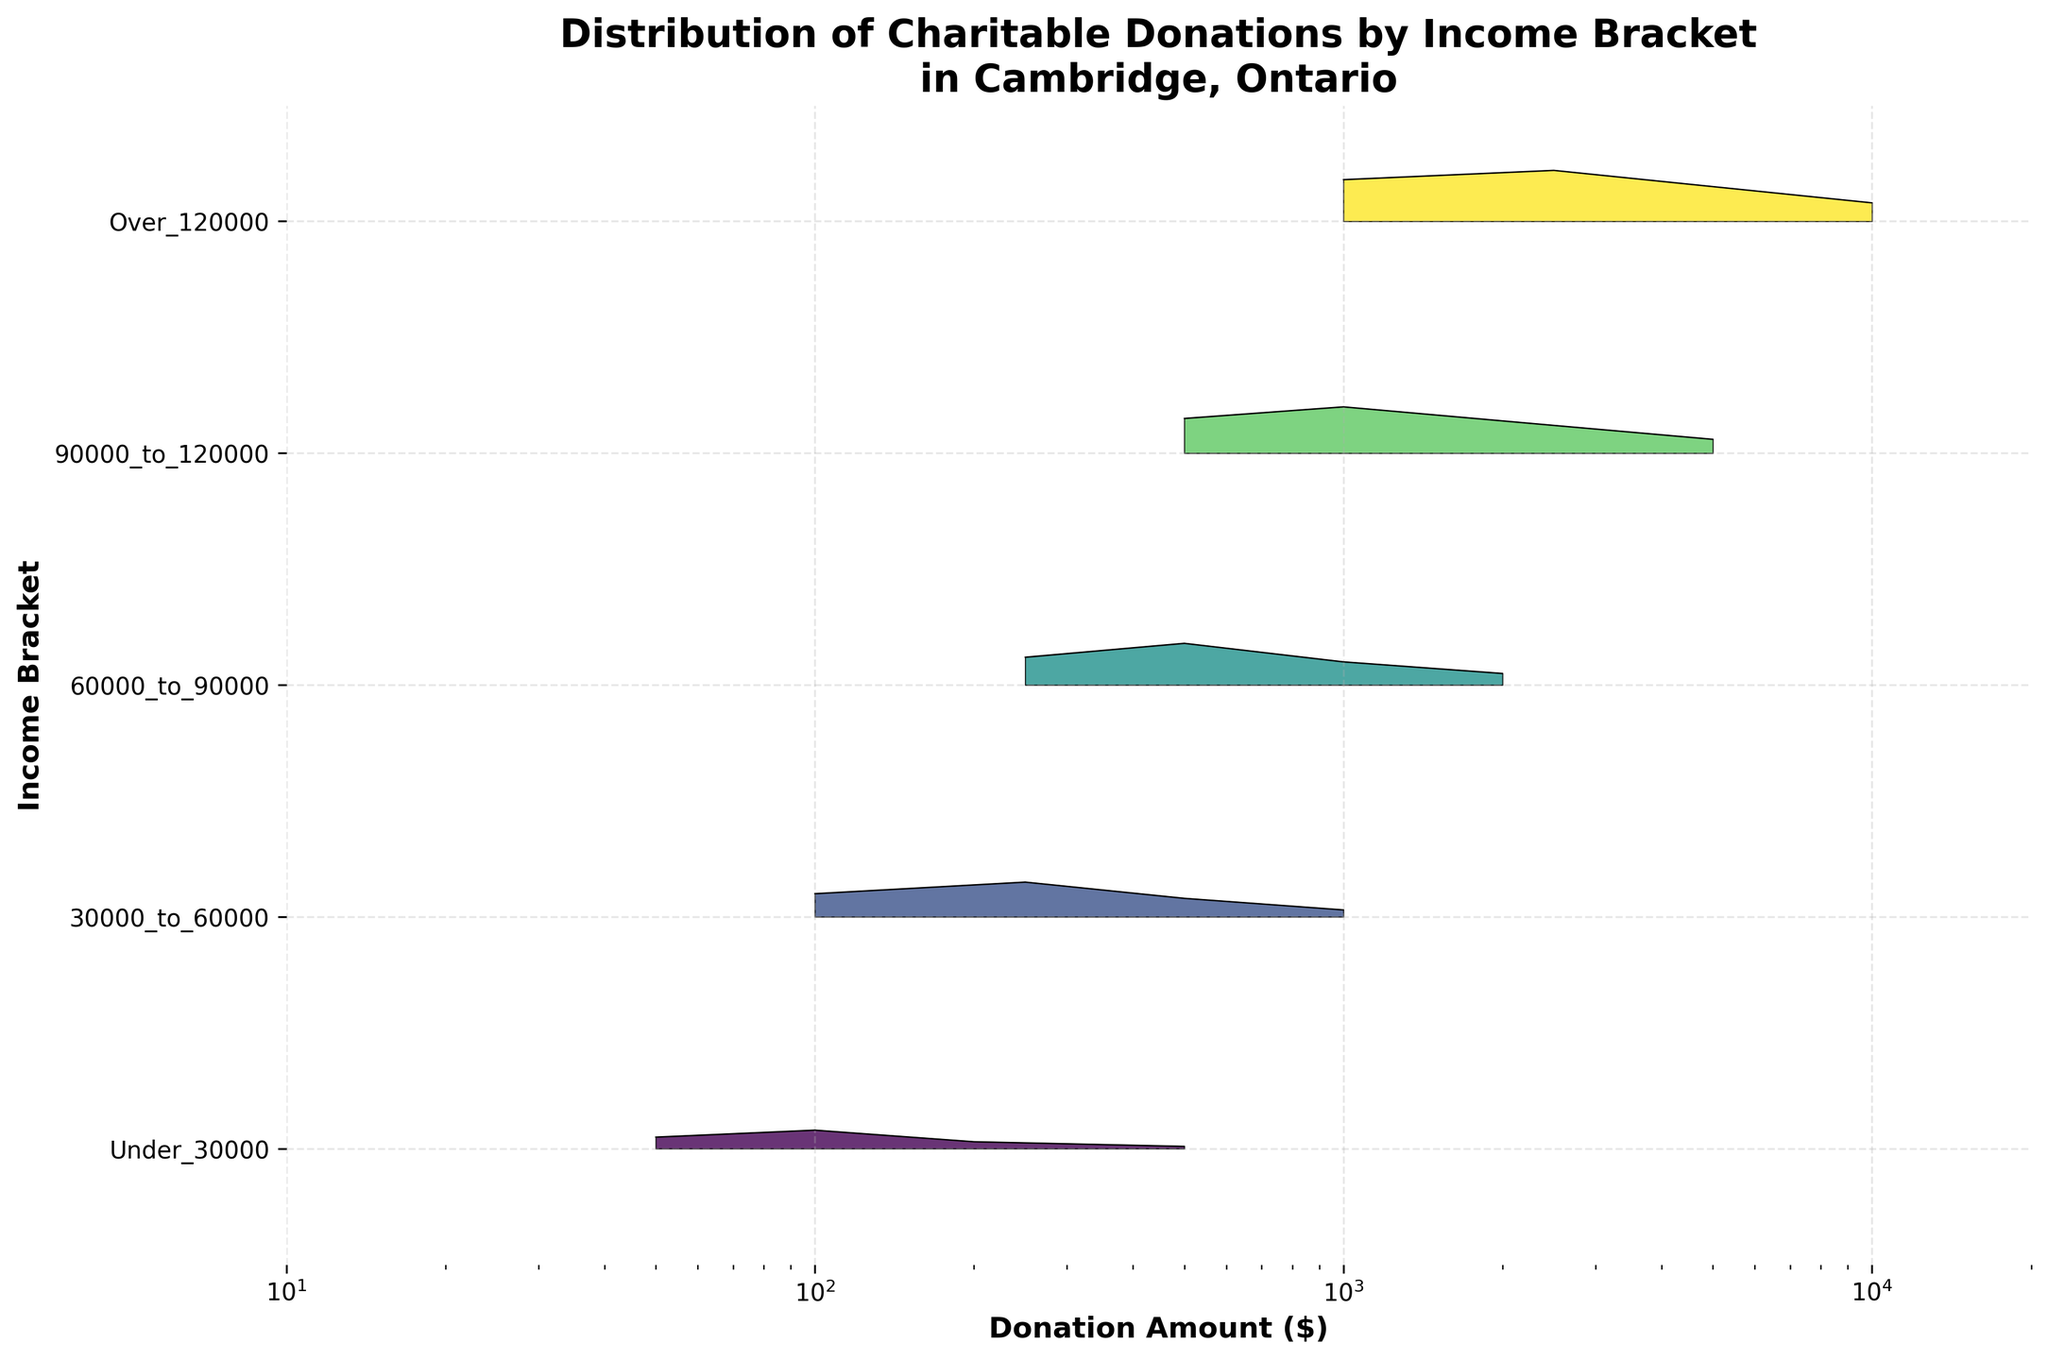what's the title of the figure? The title is located at the top of the figure and typically describes the data being visualized.
Answer: Distribution of Charitable Donations by Income Bracket in Cambridge, Ontario how many income brackets are there in the figure? The y-axis lists the different income brackets being compared. We can count the lines or labels to determine the number of brackets.
Answer: 5 which income bracket exhibits the highest variety of donation amounts? By observing the x-axis and seeing which income bracket has the broadest range of donation amounts, we can determine where the variety is highest.
Answer: Over 120000 for the "Under $30,000" bracket, what is the highest frequency observed for any donation amount? In the "Under $30,000" bracket line, the highest peak indicates the highest frequency. We look for the highest point on the plot within this segment.
Answer: 0.08 which donation value shows a frequency peak in the "90000_to_120000" bracket? Locate the "90000_to_120000" bracket's ridge, then find the point along the x-axis where the frequency reaches its peak.
Answer: 1000 compare the frequencies of $500 donations between "60000_to_90000" and "90000_to_120000" brackets. Which is higher? Identify the frequency at the $500 donation value for both the "60000_to_90000" and "90000_to_120000" ridges and compare them.
Answer: 90000_to_120000 in the "Over $120000" bracket, what donation amount has the second highest frequency? In the "Over $120000" ridge, identify the peaks and determine which donation amount corresponds to the second highest point.
Answer: 5000 which income bracket shows the least frequency for the $1000 donation amount? For the $1000 donation value, compare the heights of ridges corresponding to each income bracket to find the lowest peak.
Answer: Under $30000 what is the most common donation amount in the "30000_to_60000" bracket? For the "30000_to_60000" ridge, the x-value at the highest peak represents the most common donation amount.
Answer: 250 across all income brackets, which donation amount shows the highest overall frequency? Examine each ridge to find the highest peak in the entire plot, then identify the corresponding donation amount along the x-axis.
Answer: 2500 